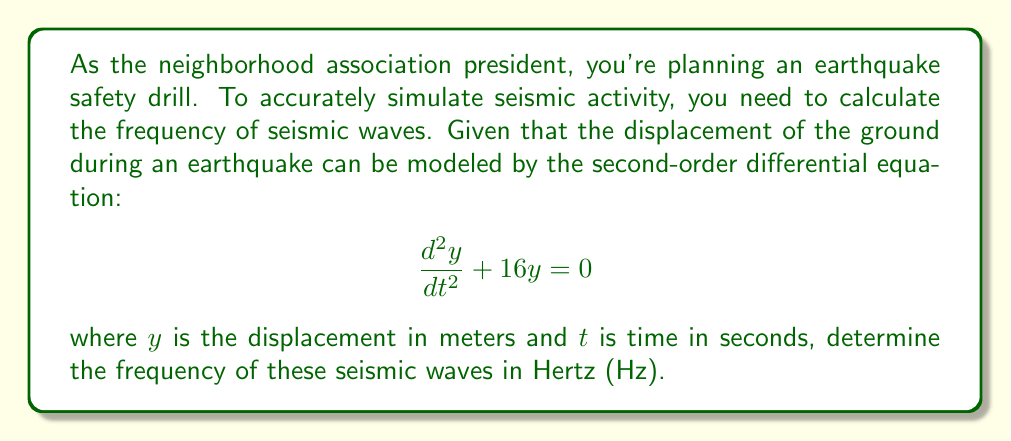Provide a solution to this math problem. To solve this problem, we'll follow these steps:

1) The given equation is a second-order linear differential equation with constant coefficients. It has the general form:

   $$\frac{d^2y}{dt^2} + \omega^2y = 0$$

   where $\omega$ is the angular frequency in radians per second.

2) In our case, $\omega^2 = 16$, so:

   $$\omega = \sqrt{16} = 4 \text{ rad/s}$$

3) The relationship between angular frequency $\omega$ and frequency $f$ in Hz is:

   $$\omega = 2\pi f$$

4) Substituting our value for $\omega$:

   $$4 = 2\pi f$$

5) Solving for $f$:

   $$f = \frac{4}{2\pi} = \frac{2}{\pi} \approx 0.6366 \text{ Hz}$$

This frequency represents how many complete oscillations occur per second in the seismic waves.
Answer: The frequency of the seismic waves is approximately 0.6366 Hz. 